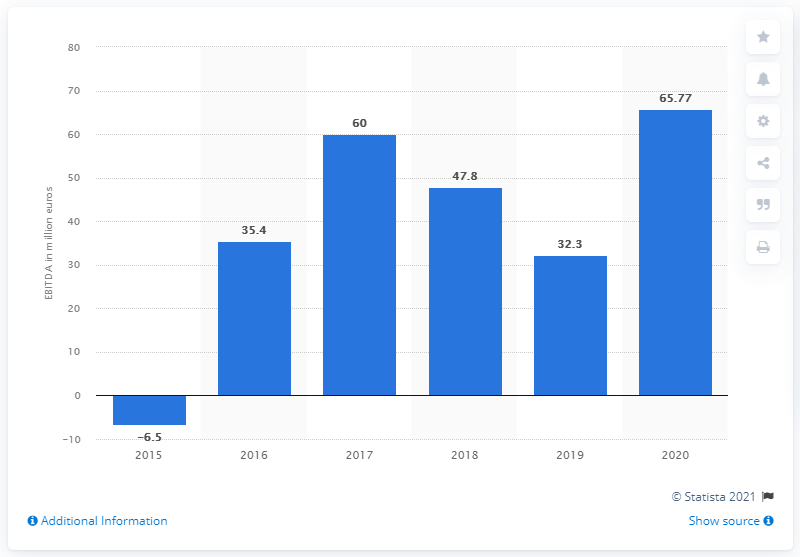Give some essential details in this illustration. The EBITDA (earnings before interest, taxes, depreciation, and amortization) of Angry Birds was 65.77. 